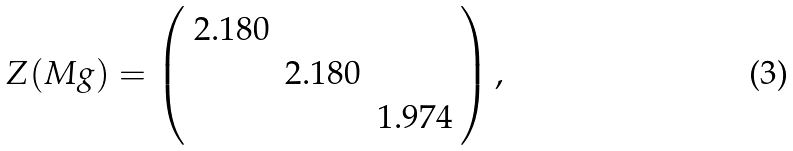Convert formula to latex. <formula><loc_0><loc_0><loc_500><loc_500>Z ( M g ) = \left ( \begin{array} { c c c } 2 . 1 8 0 & & \\ & 2 . 1 8 0 & \\ & & 1 . 9 7 4 \\ \end{array} \right ) , \quad</formula> 